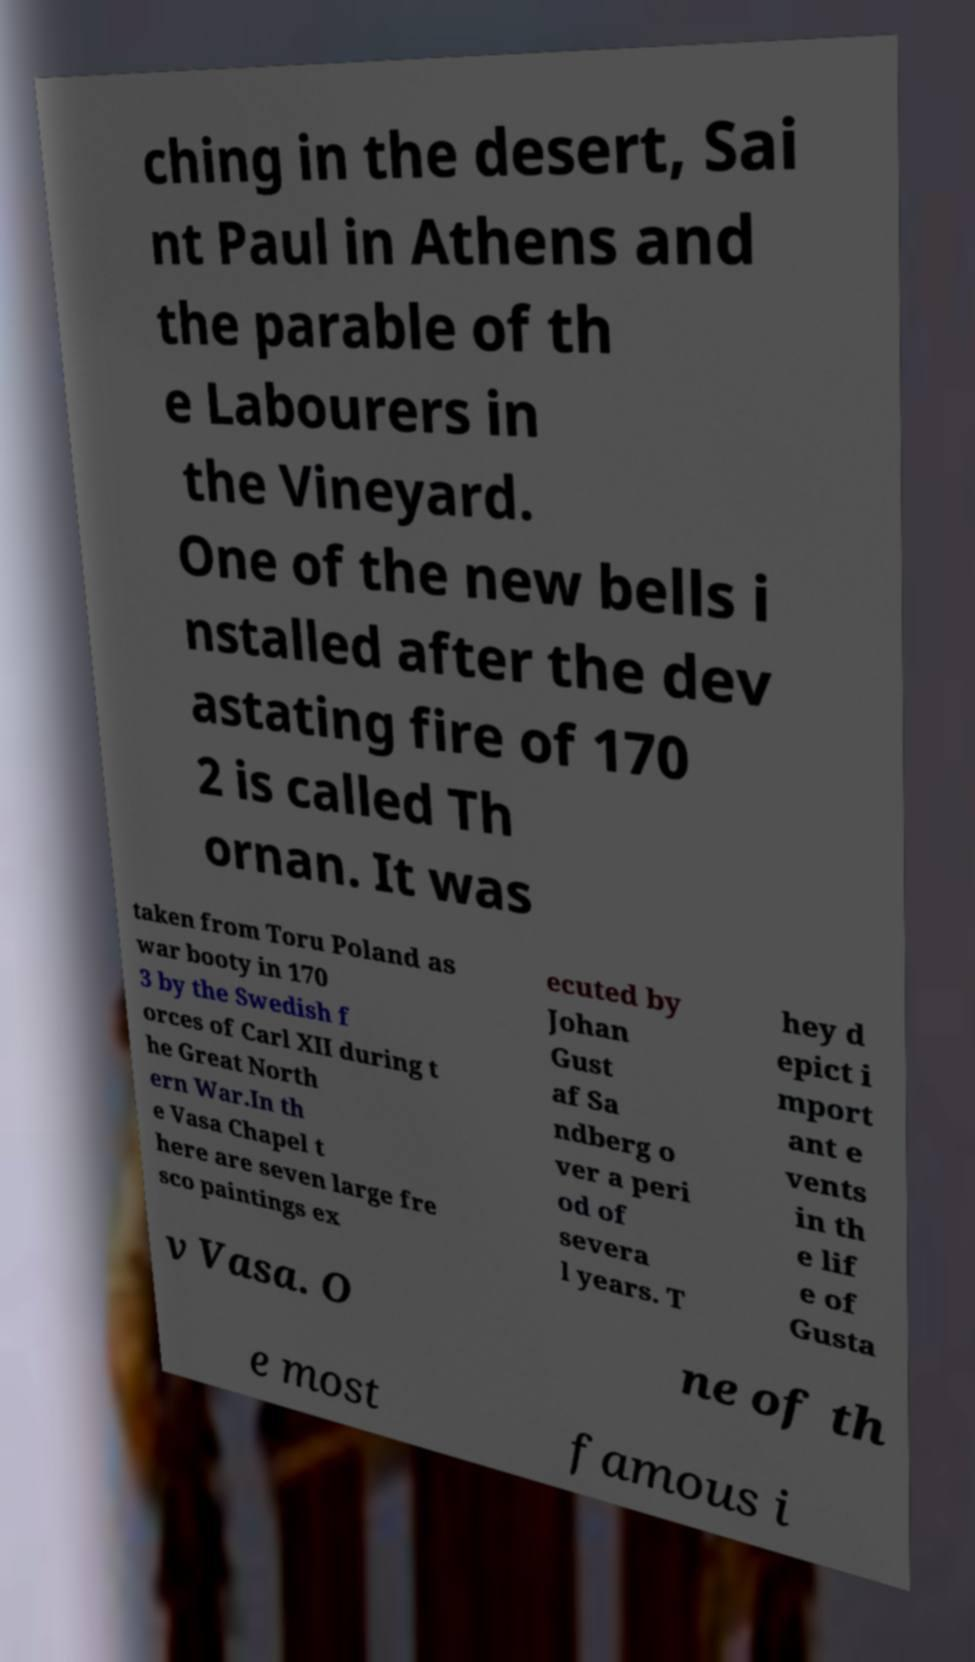Please identify and transcribe the text found in this image. ching in the desert, Sai nt Paul in Athens and the parable of th e Labourers in the Vineyard. One of the new bells i nstalled after the dev astating fire of 170 2 is called Th ornan. It was taken from Toru Poland as war booty in 170 3 by the Swedish f orces of Carl XII during t he Great North ern War.In th e Vasa Chapel t here are seven large fre sco paintings ex ecuted by Johan Gust af Sa ndberg o ver a peri od of severa l years. T hey d epict i mport ant e vents in th e lif e of Gusta v Vasa. O ne of th e most famous i 